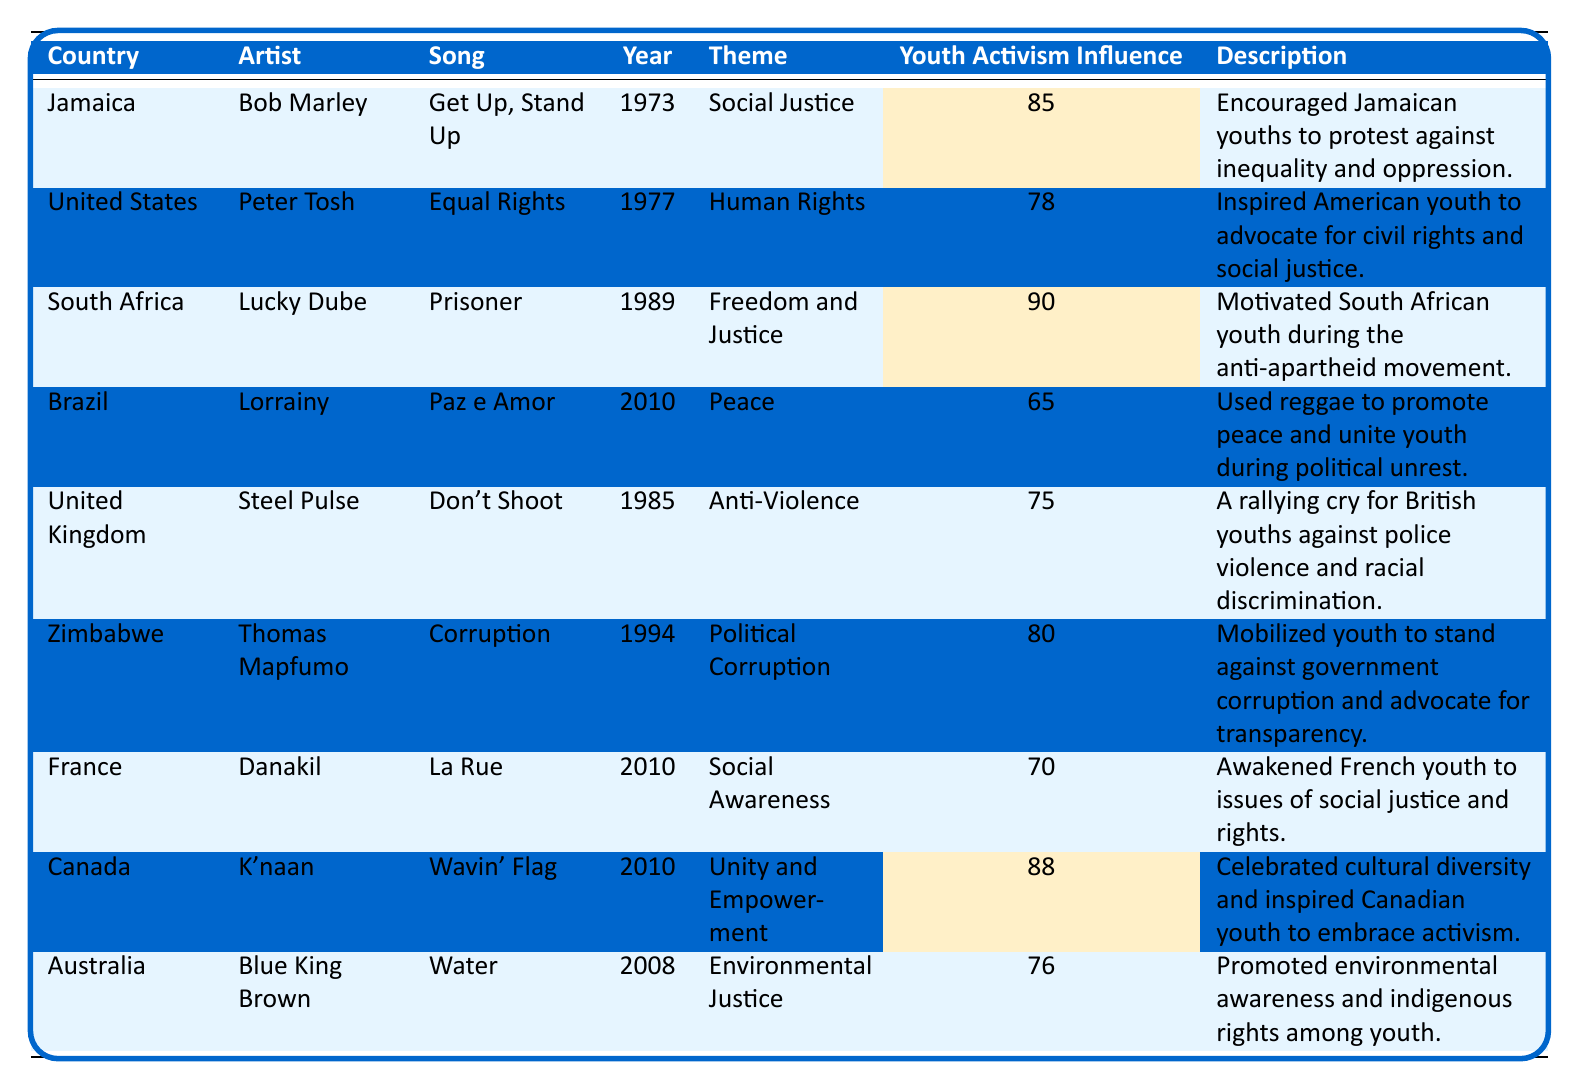What is the highest youth activism influence score in the table? The highest score in the youth activism influence column is 90, which corresponds to the song "Prisoner" by Lucky Dube from South Africa.
Answer: 90 Which country has a reggae song celebrating cultural diversity? The song "Wavin' Flag" by K'naan from Canada celebrates cultural diversity and has a youth activism influence score of 88.
Answer: Canada How many countries have a youth activism influence score of 80 or above? The scores of 85 (Jamaica), 90 (South Africa), and 88 (Canada) are all 80 or above, making a total of 3 countries.
Answer: 3 Which artist's song talks about environmental justice, and what is its influence score? The artist Blue King Brown from Australia has the song "Water" which focuses on environmental justice, and its influence score is 76.
Answer: Blue King Brown, 76 Is the song "Get Up, Stand Up" more influential than "Don't Shoot"? "Get Up, Stand Up" has a score of 85, while "Don't Shoot" has a score of 75. Since 85 is greater than 75, it is indeed more influential.
Answer: Yes What is the average youth activism influence score of the songs listed for South Africa and Zimbabwe? The scores for South Africa (90) and Zimbabwe (80) need to be summed (90 + 80 = 170) and then divided by 2, resulting in an average score of 85.
Answer: 85 Which theme has the least influence score, and what is that score? The theme "Peace" represented by the song "Paz e Amor" from Brazil has the lowest influence score of 65, which is the least among all listed themes.
Answer: Peace, 65 Is there a song from the United Kingdom that tackles police violence, and what is its influence score? The song "Don't Shoot" by Steel Pulse from the United Kingdom addresses police violence, and it has an influence score of 75.
Answer: Yes, 75 What year was the song "Equal Rights" released? "Equal Rights" by Peter Tosh was released in 1977, as indicated in the year column.
Answer: 1977 If we list all songs with an influence score above 70, how many songs are there, and which countries do they represent? The songs with scores above 70 are from Jamaica (85), South Africa (90), United States (78), Zimbabwe (80), Canada (88), and Australia (76), totaling 6 songs.
Answer: 6, Jamaica, South Africa, United States, Zimbabwe, Canada, Australia 